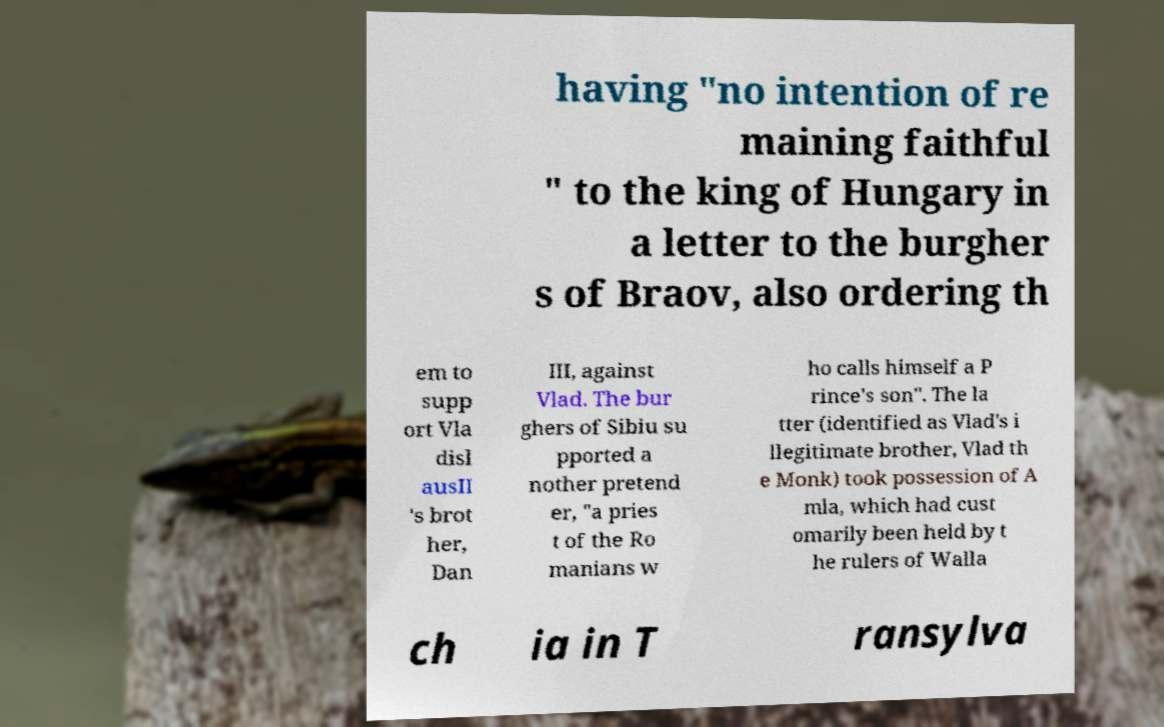Please read and relay the text visible in this image. What does it say? having "no intention of re maining faithful " to the king of Hungary in a letter to the burgher s of Braov, also ordering th em to supp ort Vla disl ausII 's brot her, Dan III, against Vlad. The bur ghers of Sibiu su pported a nother pretend er, "a pries t of the Ro manians w ho calls himself a P rince's son". The la tter (identified as Vlad's i llegitimate brother, Vlad th e Monk) took possession of A mla, which had cust omarily been held by t he rulers of Walla ch ia in T ransylva 